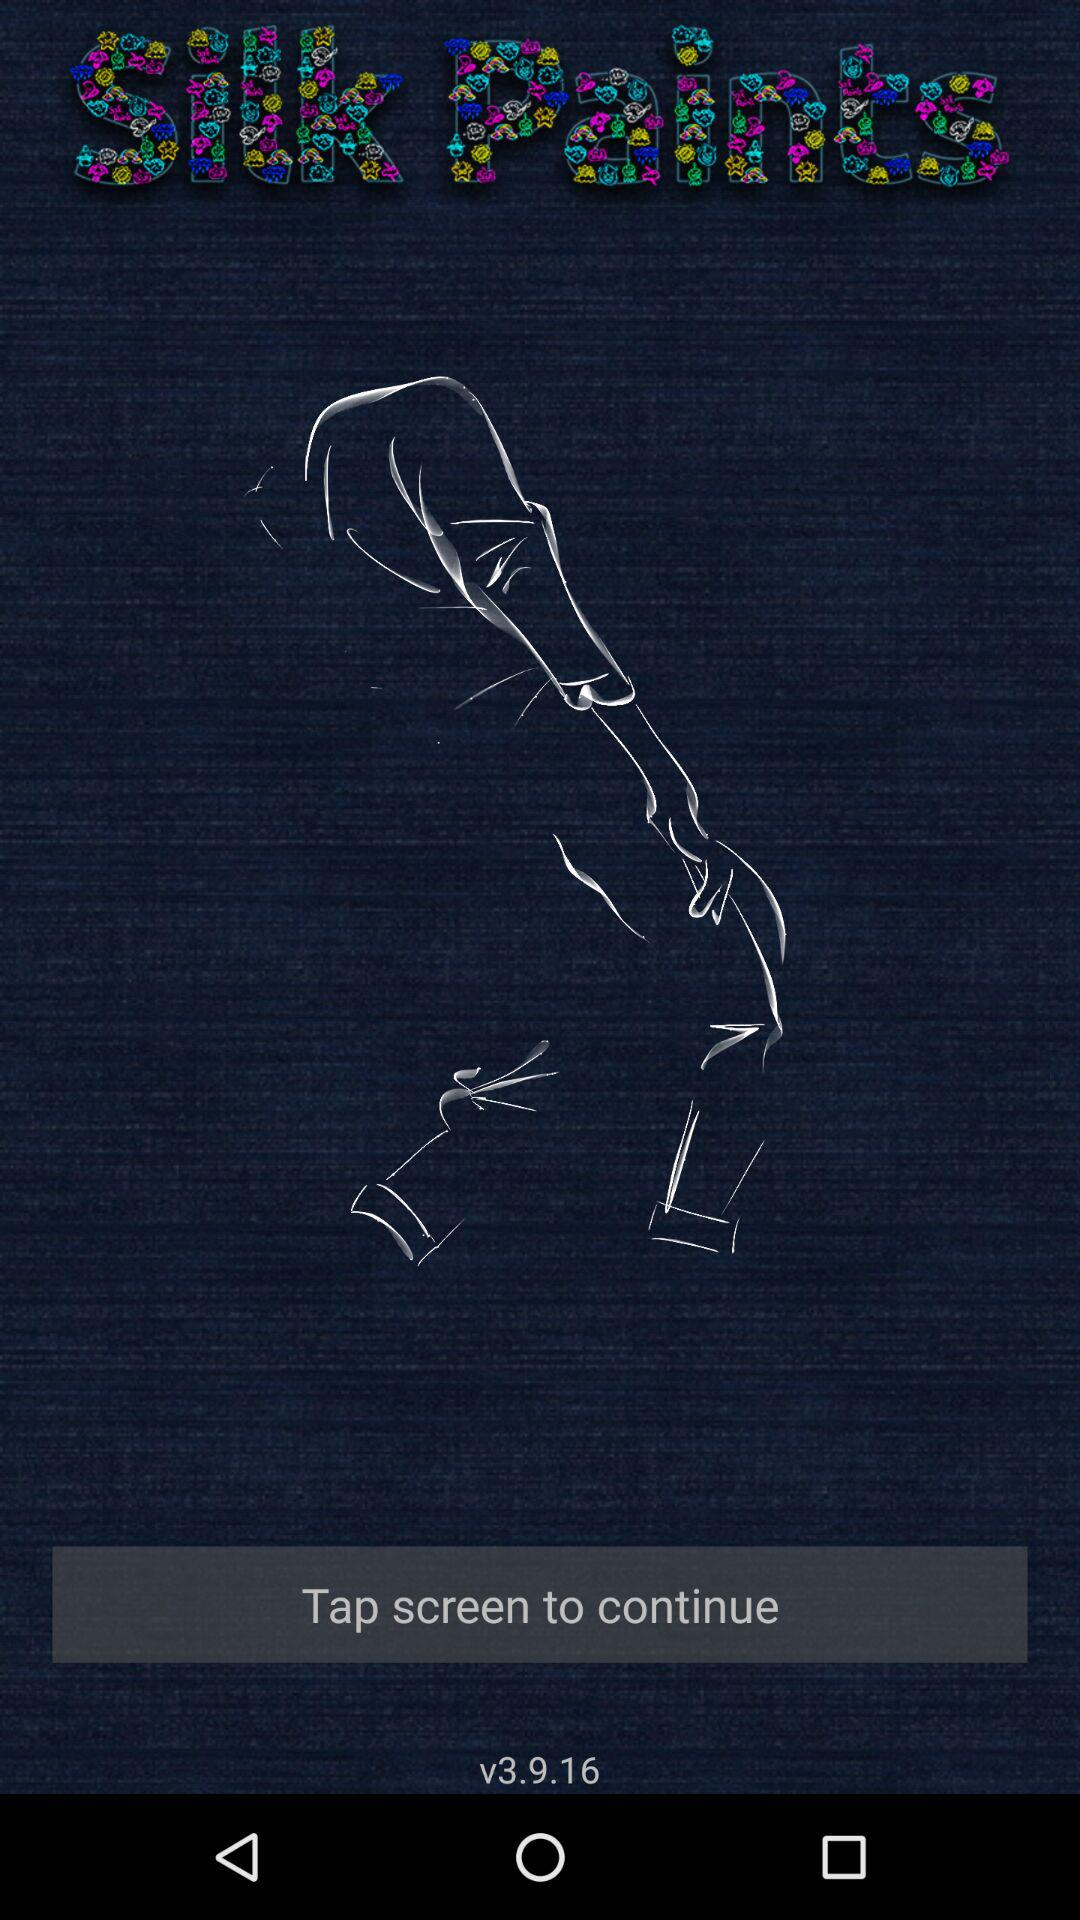What is the version? The version is v3.9.16. 